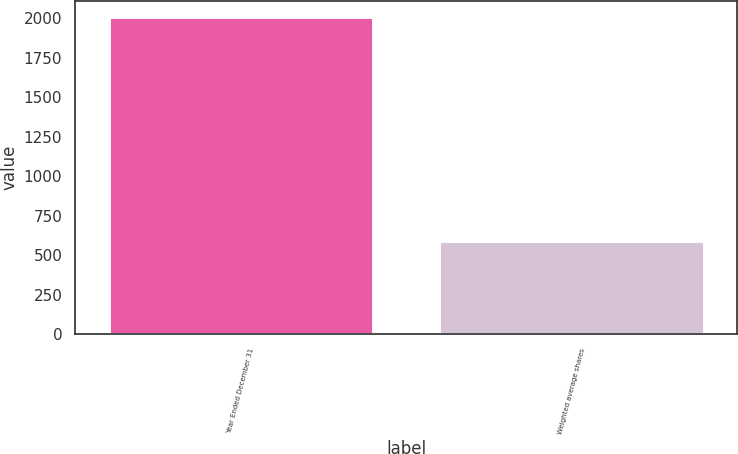Convert chart. <chart><loc_0><loc_0><loc_500><loc_500><bar_chart><fcel>Year Ended December 31<fcel>Weighted average shares<nl><fcel>2009<fcel>590.43<nl></chart> 